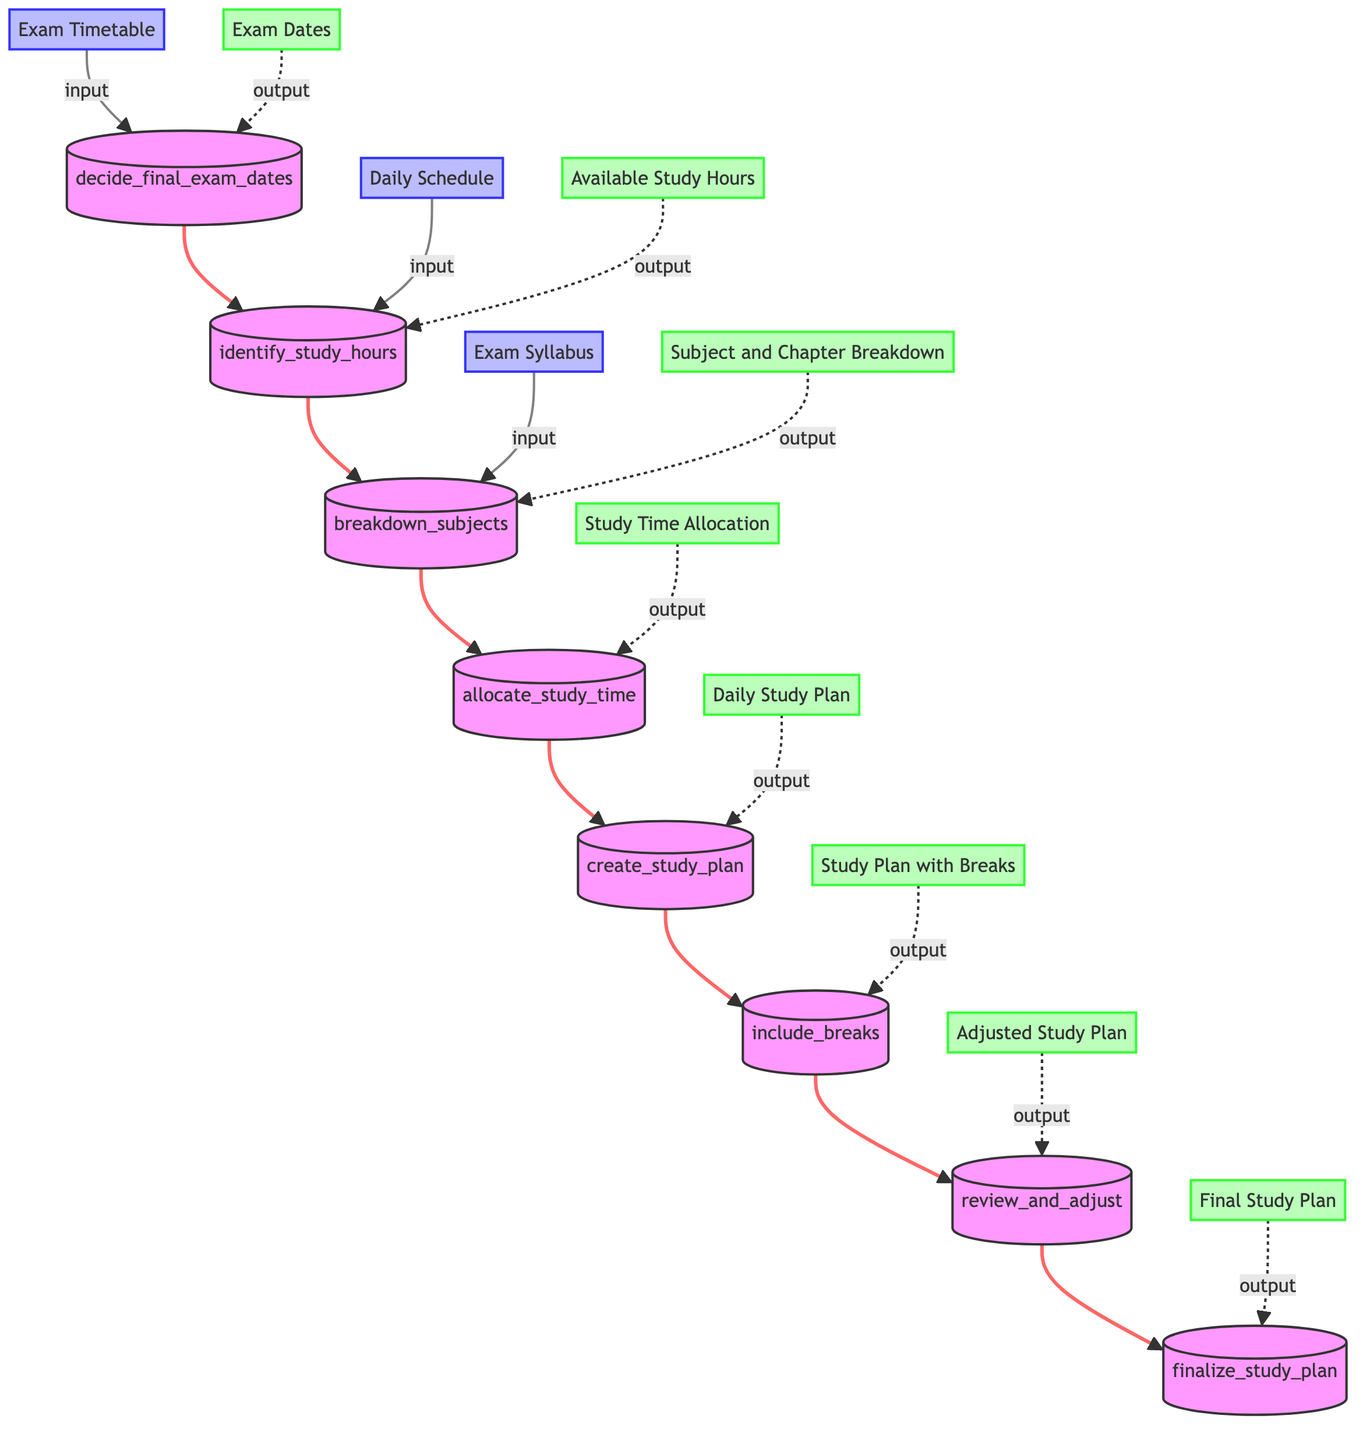what is the first step in the study schedule planning process? The first step in the flowchart is "decide_final_exam_dates", which refers to listing out all final exam dates and subjects.
Answer: decide_final_exam_dates how many output nodes are in the diagram? The diagram includes eight output nodes, one for each of the steps that culminate in the final study plan.
Answer: eight which step follows after the allocation of study time? After "allocate_study_time", the next step is "create_study_plan". This means that after distributing study hours, the next action is to generate a daily study schedule.
Answer: create_study_plan what is the input for the "include_breaks" step? The input for the "include_breaks" step is the "Daily Study Plan", which is assembled before this stage to incorporate breaks and relaxation periods effectively.
Answer: Daily Study Plan how does the "review_and_adjust" step relate to the "finalize_study_plan" step? "review_and_adjust" outputs an "Adjusted Study Plan", which serves as the input for the "finalize_study_plan". Therefore, the previous step's adjustments directly influence the finalization process.
Answer: Adjusted Study Plan what is the last output of the diagram? The last output of the diagram is the "Final Study Plan", which is produced after reviewing and adjusting the earlier study plan.
Answer: Final Study Plan which inputs are involved in the "allocate_study_time" step? The inputs for the "allocate_study_time" step include "Available Study Hours" and "Subject and Chapter Breakdown", as both pieces of information are necessary to distribute the study time.
Answer: Available Study Hours, Subject and Chapter Breakdown what happens to the study plan at the end of each week? At the end of each week, the "review_and_adjust" step processes the "Study Plan with Breaks" to ensure that it is effective and make necessary changes.
Answer: review_and_adjust 